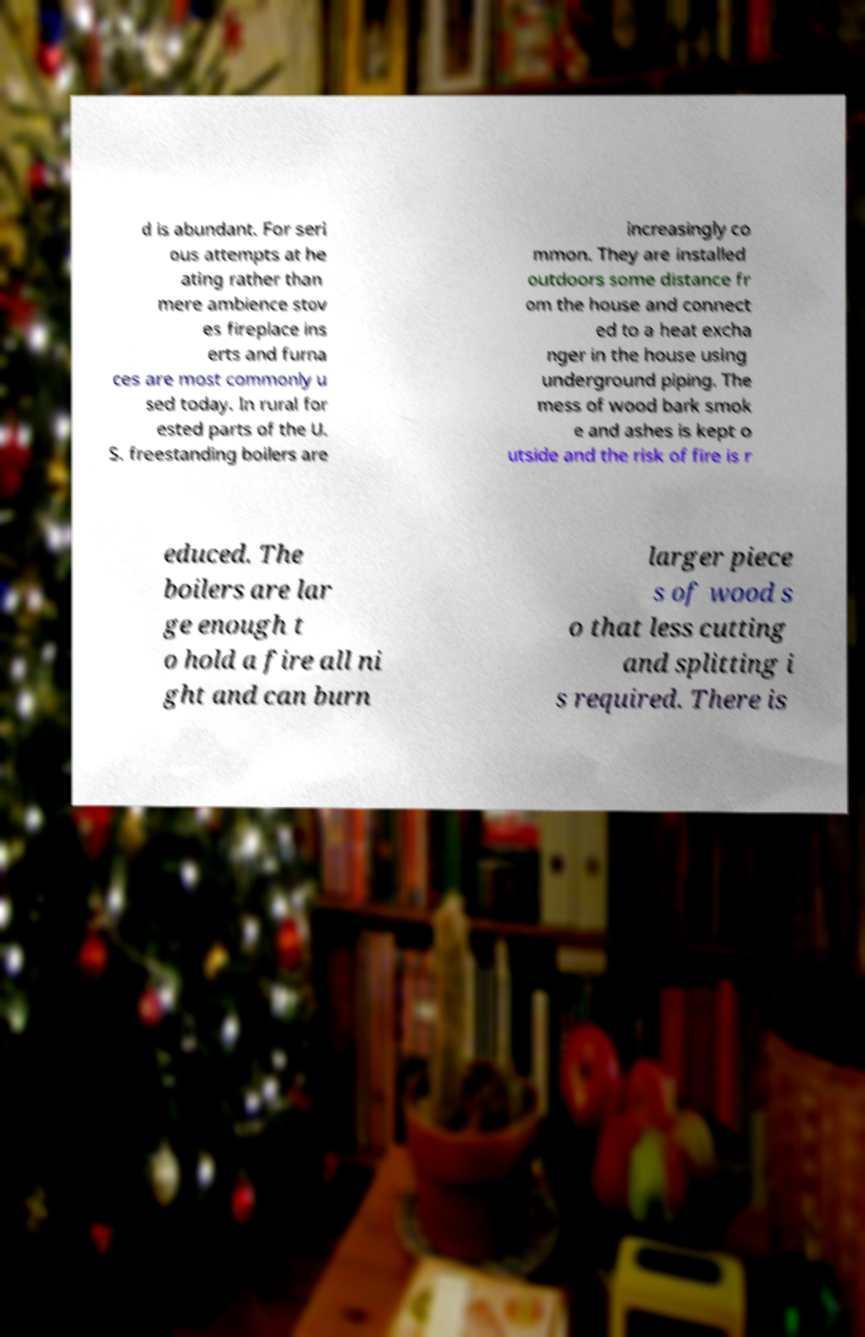What messages or text are displayed in this image? I need them in a readable, typed format. d is abundant. For seri ous attempts at he ating rather than mere ambience stov es fireplace ins erts and furna ces are most commonly u sed today. In rural for ested parts of the U. S. freestanding boilers are increasingly co mmon. They are installed outdoors some distance fr om the house and connect ed to a heat excha nger in the house using underground piping. The mess of wood bark smok e and ashes is kept o utside and the risk of fire is r educed. The boilers are lar ge enough t o hold a fire all ni ght and can burn larger piece s of wood s o that less cutting and splitting i s required. There is 